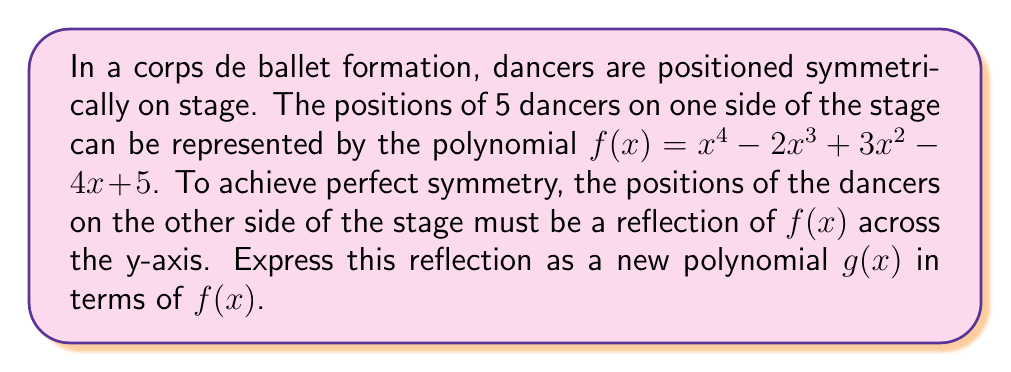Give your solution to this math problem. To reflect a polynomial across the y-axis, we need to replace every x with -x in the original function. This process can be broken down into steps:

1) Start with $f(x) = x^4 - 2x^3 + 3x^2 - 4x + 5$

2) Replace every x with -x:
   $f(-x) = (-x)^4 - 2(-x)^3 + 3(-x)^2 - 4(-x) + 5$

3) Simplify each term:
   - $(-x)^4 = x^4$ (even power, sign doesn't change)
   - $-2(-x)^3 = 2x^3$ (odd power, sign changes)
   - $3(-x)^2 = 3x^2$ (even power, sign doesn't change)
   - $-4(-x) = 4x$ (first power, sign changes)
   - The constant term 5 remains unchanged

4) Combining the terms:
   $g(x) = x^4 + 2x^3 + 3x^2 + 4x + 5$

5) We can express this in terms of $f(x)$:
   $g(x) = f(-x)$

This transformation creates a perfect mirror image of the original formation across the y-axis, allowing the ballet dancer to visualize and execute the symmetrical positioning with precision.
Answer: $g(x) = f(-x)$ 